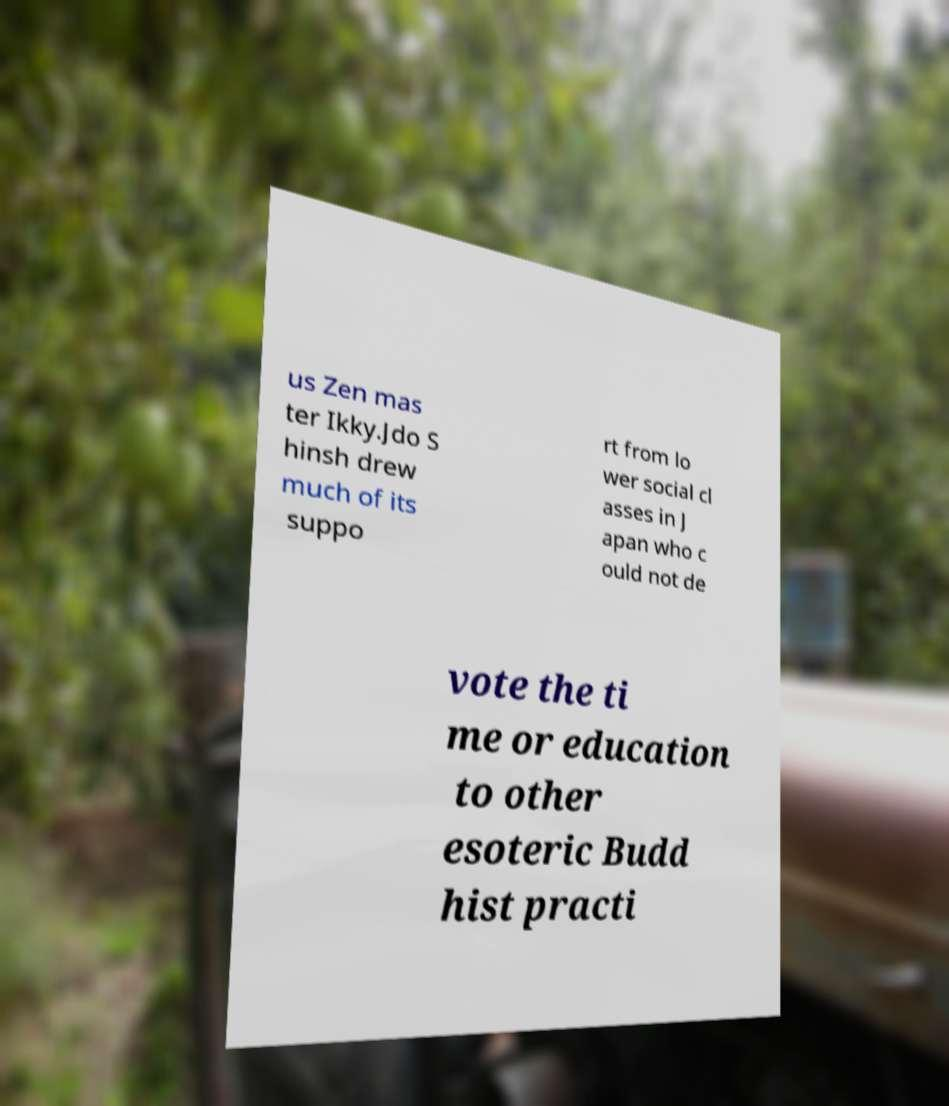Can you read and provide the text displayed in the image?This photo seems to have some interesting text. Can you extract and type it out for me? us Zen mas ter Ikky.Jdo S hinsh drew much of its suppo rt from lo wer social cl asses in J apan who c ould not de vote the ti me or education to other esoteric Budd hist practi 